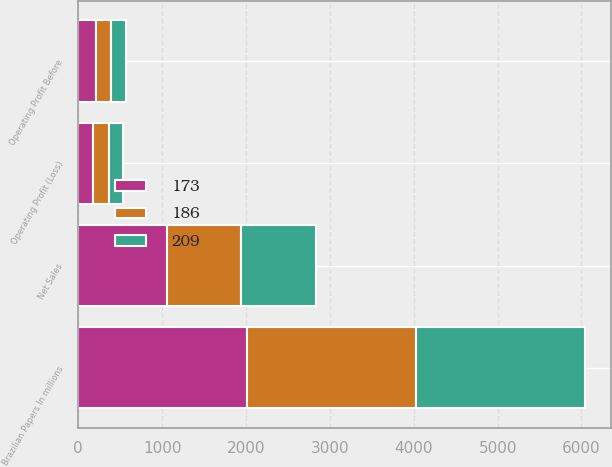Convert chart. <chart><loc_0><loc_0><loc_500><loc_500><stacked_bar_chart><ecel><fcel>Brazilian Papers In millions<fcel>Net Sales<fcel>Operating Profit (Loss)<fcel>Operating Profit Before<nl><fcel>209<fcel>2016<fcel>897<fcel>173<fcel>173<nl><fcel>186<fcel>2015<fcel>878<fcel>186<fcel>186<nl><fcel>173<fcel>2014<fcel>1061<fcel>177<fcel>209<nl></chart> 